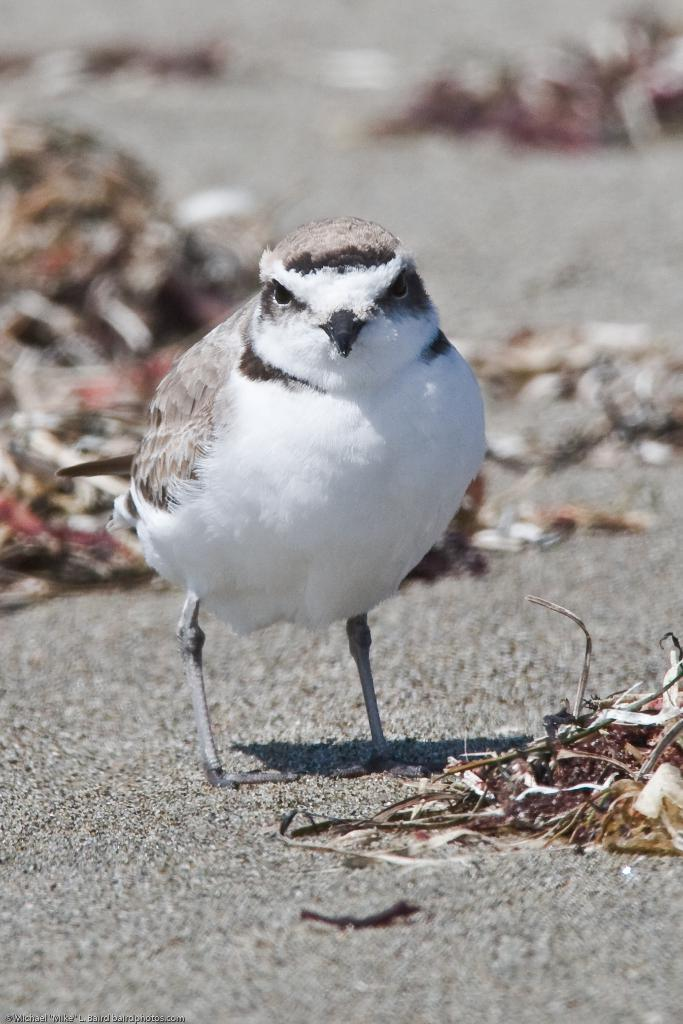What type of animal can be seen in the picture? There is a bird in the picture. What objects are on the floor in the image? There are twigs and dry leaves on the floor. What type of cream can be seen on the bird's feathers in the image? There is no cream visible on the bird's feathers in the image. Can you tell me how the robin is controlling the twigs in the image? There is no robin present in the image, and therefore no control over twigs can be observed. 